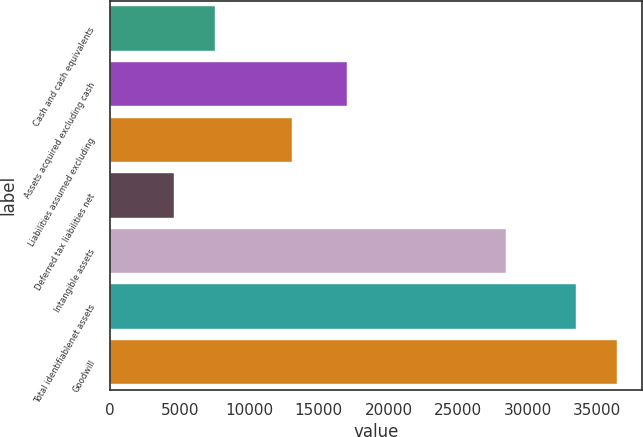<chart> <loc_0><loc_0><loc_500><loc_500><bar_chart><fcel>Cash and cash equivalents<fcel>Assets acquired excluding cash<fcel>Liabilities assumed excluding<fcel>Deferred tax liabilities net<fcel>Intangible assets<fcel>Total identifiablenet assets<fcel>Goodwill<nl><fcel>7513.3<fcel>17050<fcel>13064<fcel>4610<fcel>28414<fcel>33475<fcel>36378.3<nl></chart> 